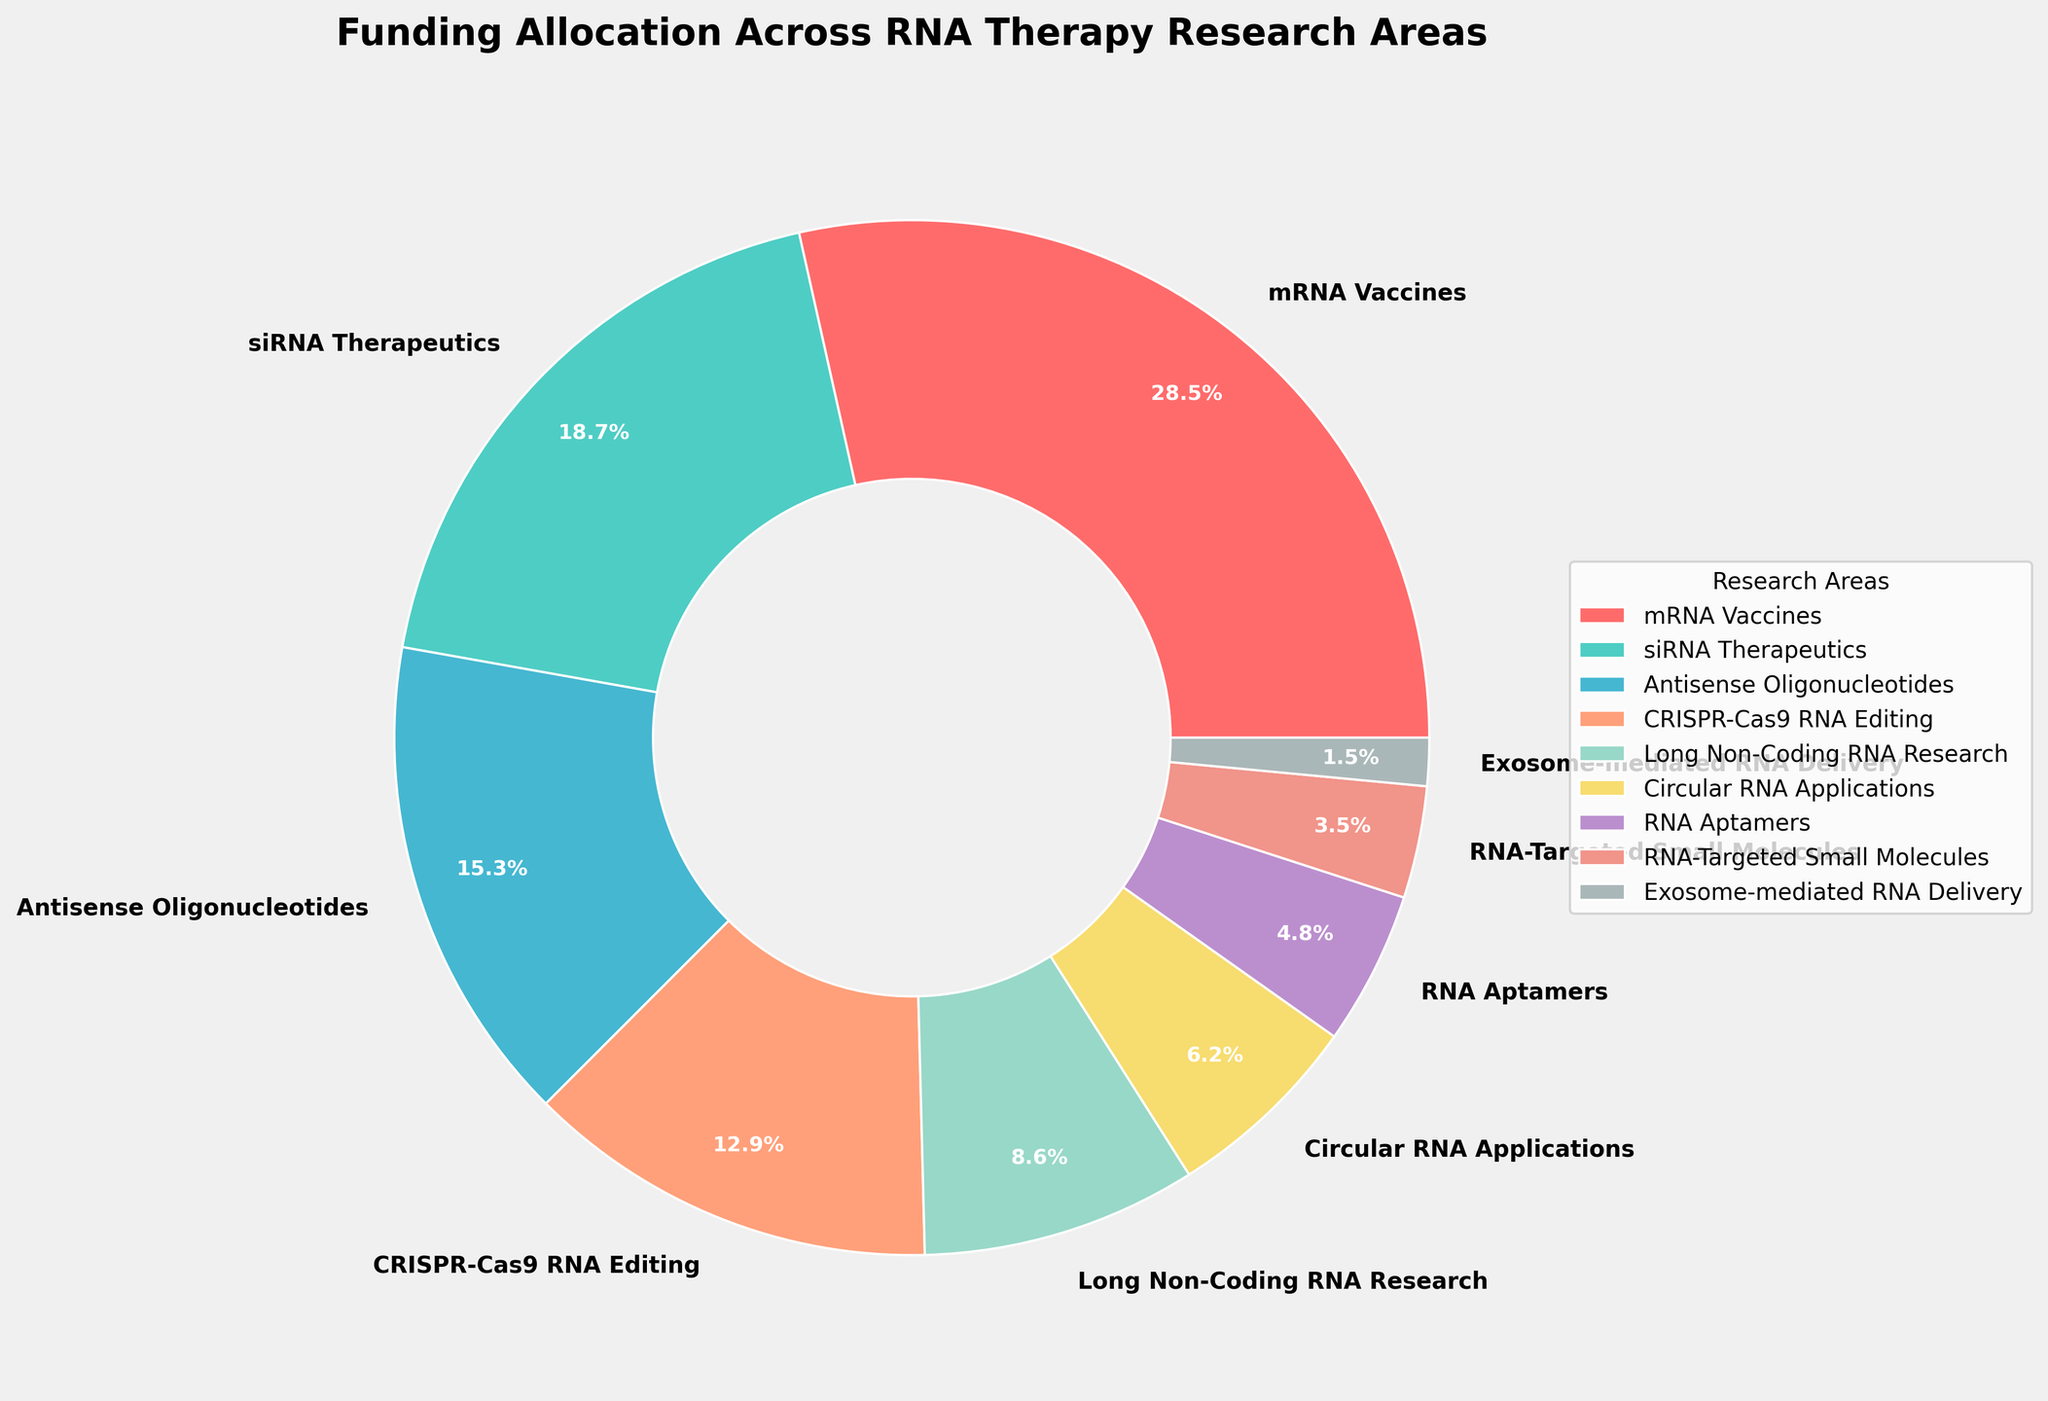Which RNA therapy research area received the highest funding allocation? The pie chart shows that "mRNA Vaccines" has the largest wedge by percentage, specifically labeled as 28.5%.
Answer: mRNA Vaccines Which two research areas have the smallest funding allocations? Looking at the pie chart, the smallest wedges correspond to "Exosome-mediated RNA Delivery" with 1.5% and "RNA-Targeted Small Molecules" with 3.5%.
Answer: Exosome-mediated RNA Delivery and RNA-Targeted Small Molecules What is the combined funding percentage for CRISPR-Cas9 RNA Editing and Long Non-Coding RNA Research? The funding percentages for "CRISPR-Cas9 RNA Editing" and "Long Non-Coding RNA Research" are 12.9% and 8.6%, respectively. Adding those together, 12.9 + 8.6 = 21.5%.
Answer: 21.5% How does the funding for siRNA Therapeutics compare to that of Antisense Oligonucleotides? The funding percentage for "siRNA Therapeutics" is 18.7%, while that for "Antisense Oligonucleotides" is 15.3%. 18.7% is greater than 15.3%.
Answer: siRNA Therapeutics receives more funding than Antisense Oligonucleotides Which research area has a funding percentage closest to 10%? By examining the pie chart, the research area closest to 10% is "CRISPR-Cas9 RNA Editing" with a funding percentage of 12.9%.
Answer: CRISPR-Cas9 RNA Editing What is the total funding percentage allocated to research areas with less than 10% funding each? From the chart, the areas with less than 10% are "Long Non-Coding RNA Research" (8.6%), "Circular RNA Applications" (6.2%), "RNA Aptamers" (4.8%), "RNA-Targeted Small Molecules" (3.5%), "Exosome-mediated RNA Delivery" (1.5%). Summing these, 8.6 + 6.2 + 4.8 + 3.5 + 1.5 = 24.6%.
Answer: 24.6% Which research area has a funding allocation represented by the yellow segment? The yellow segment according to the customized color palette is "Long Non-Coding RNA Research."
Answer: Long Non-Coding RNA Research How much more funding does mRNA Vaccines receive compared to Circular RNA Applications? The funding for "mRNA Vaccines" is 28.5%, and for "Circular RNA Applications" it is 6.2%. The difference is 28.5% - 6.2% = 22.3%.
Answer: 22.3% What is the average funding percentage for RNA Aptamers, RNA-Targeted Small Molecules, and Exosome-mediated RNA Delivery? The funding percentages for these areas are 4.8%, 3.5%, and 1.5%. To find the average: (4.8 + 3.5 + 1.5) / 3 = 9.8 / 3 ≈ 3.27%.
Answer: 3.27% 